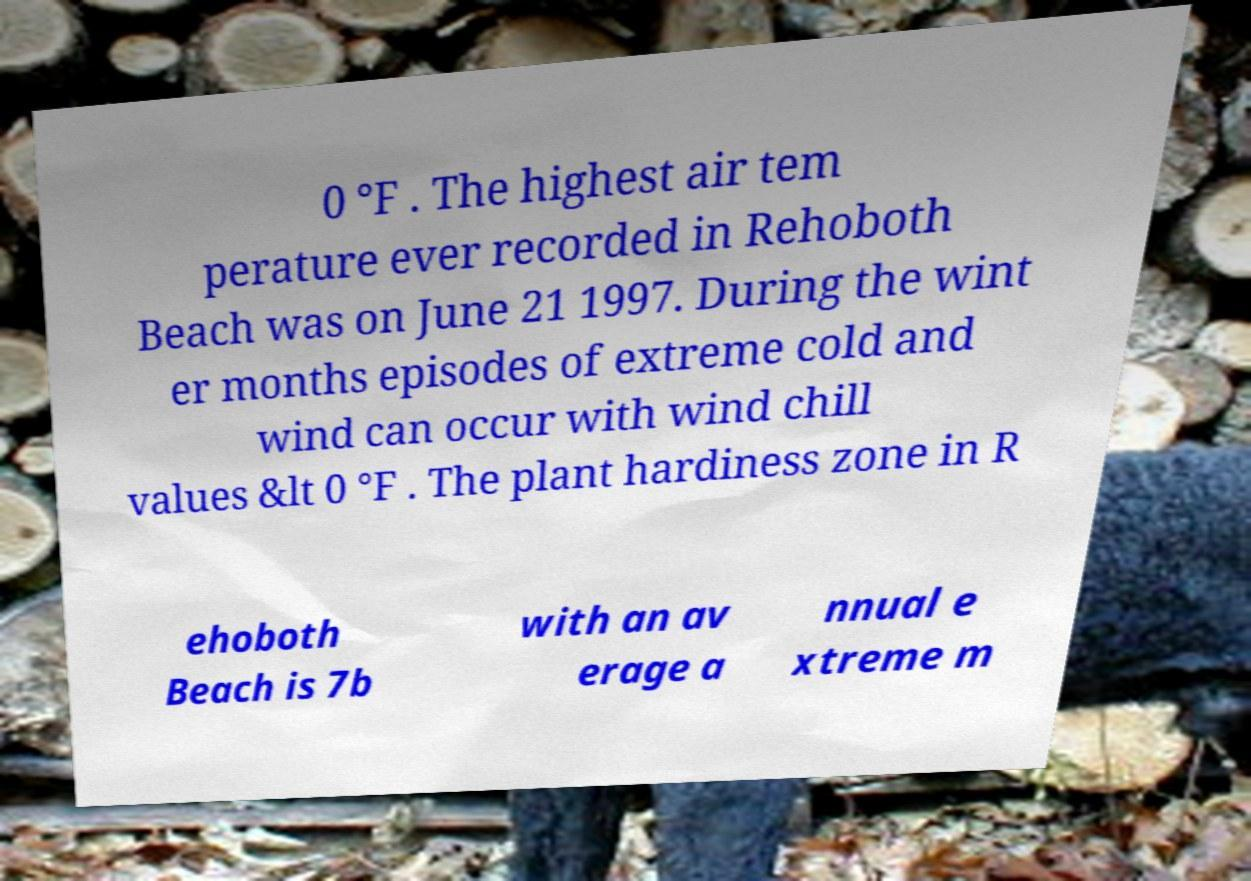There's text embedded in this image that I need extracted. Can you transcribe it verbatim? 0 °F . The highest air tem perature ever recorded in Rehoboth Beach was on June 21 1997. During the wint er months episodes of extreme cold and wind can occur with wind chill values &lt 0 °F . The plant hardiness zone in R ehoboth Beach is 7b with an av erage a nnual e xtreme m 